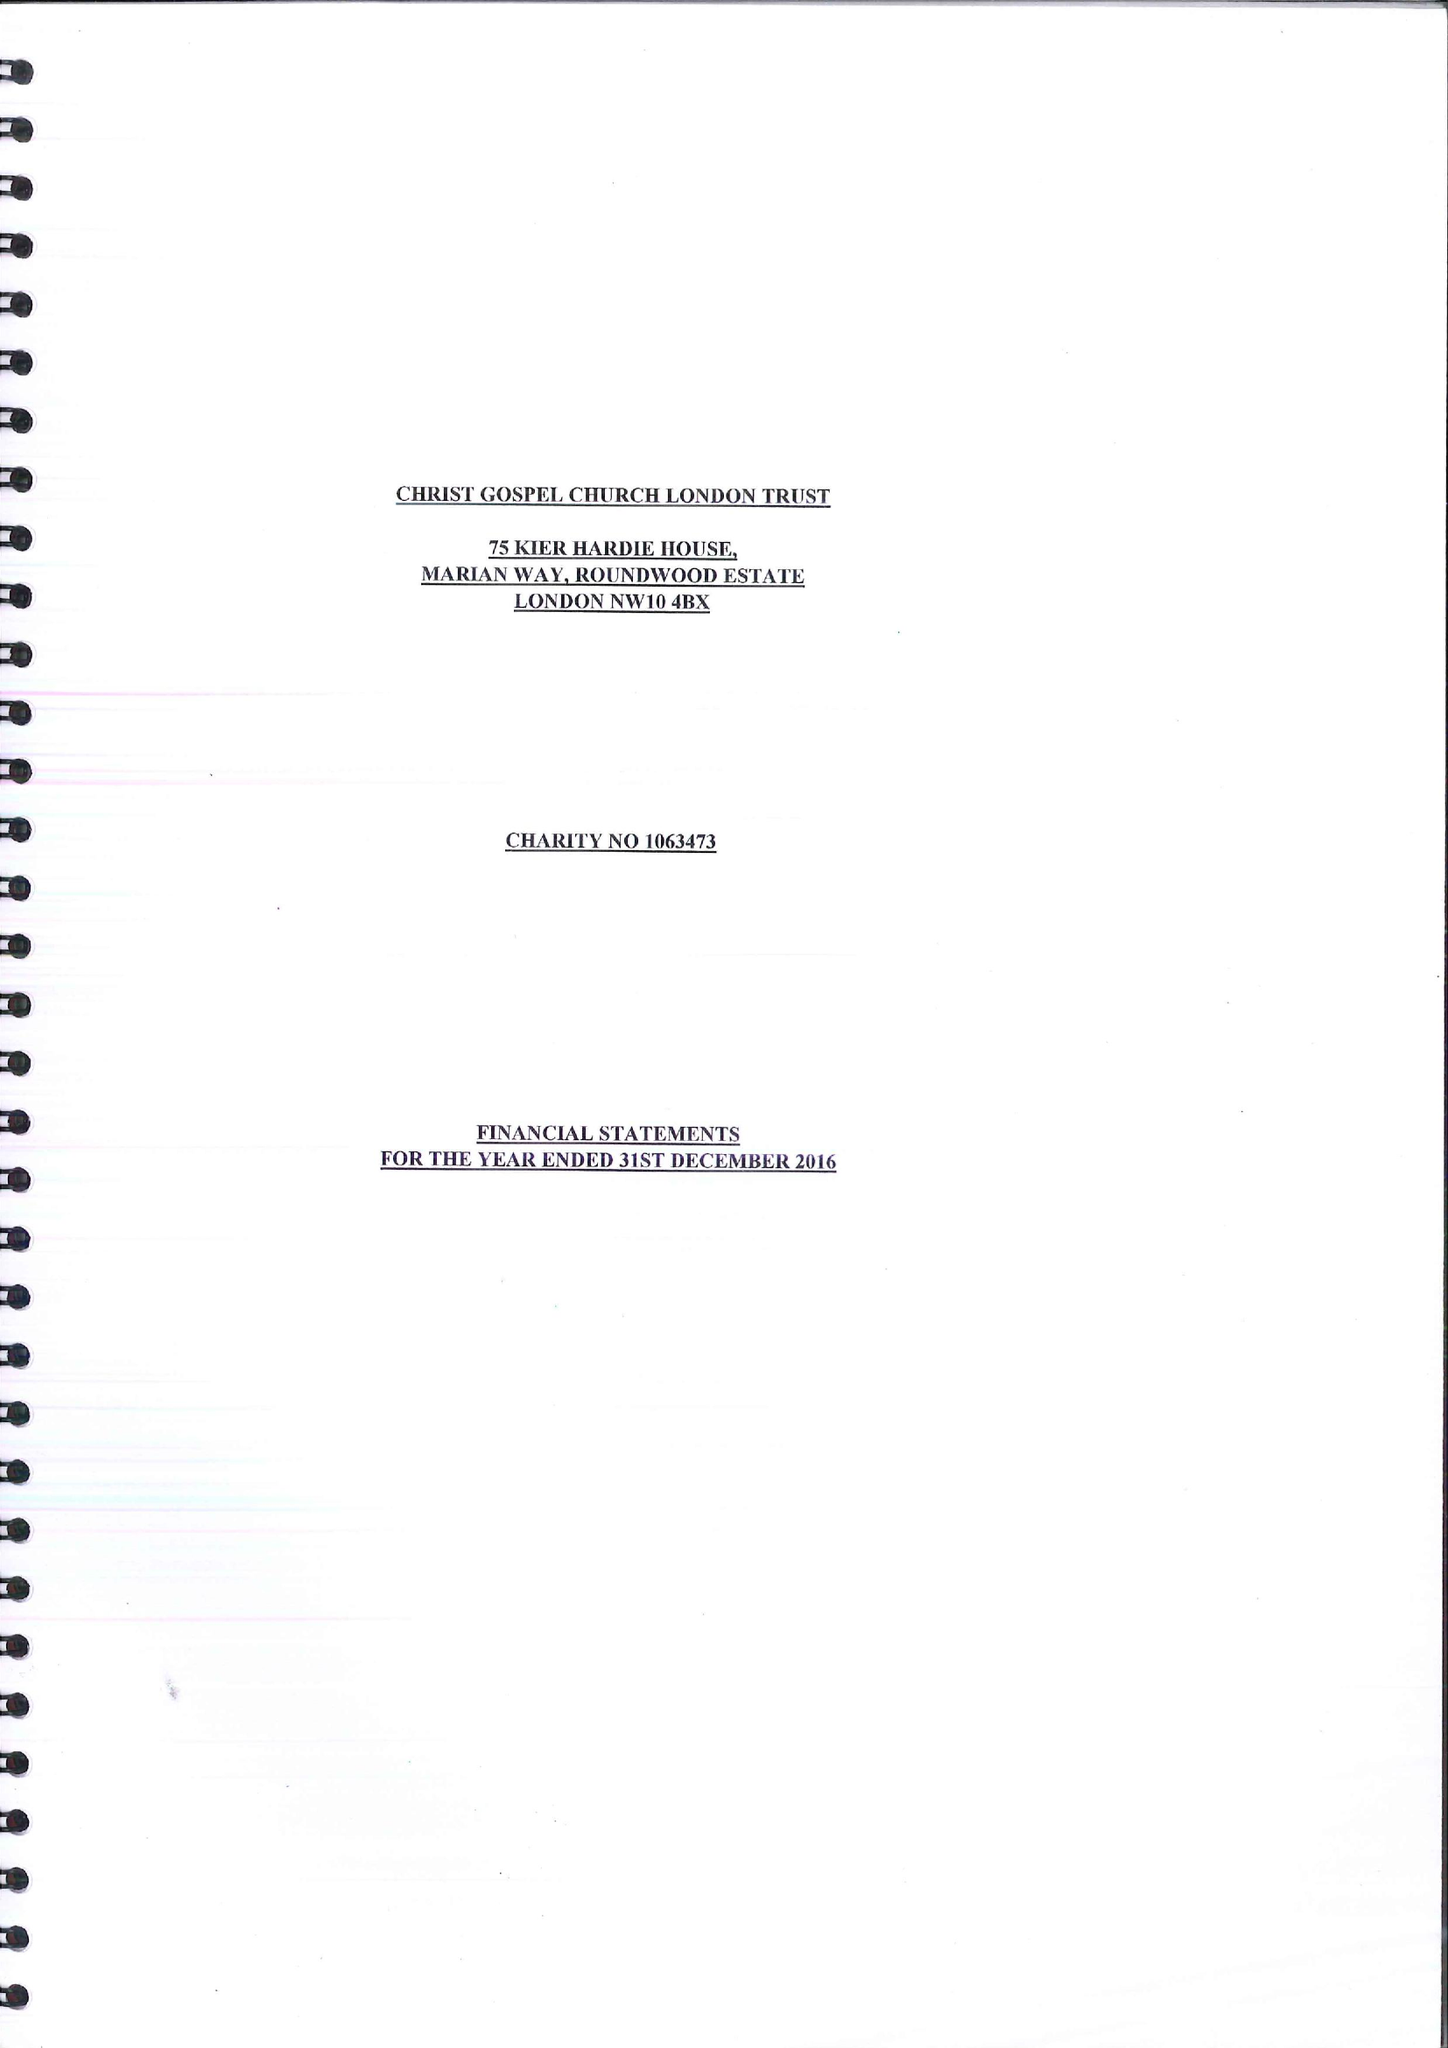What is the value for the address__street_line?
Answer the question using a single word or phrase. MARIAN WAY 